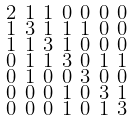<formula> <loc_0><loc_0><loc_500><loc_500>\begin{smallmatrix} 2 & 1 & 1 & 0 & 0 & 0 & 0 \\ 1 & 3 & 1 & 1 & 1 & 0 & 0 \\ 1 & 1 & 3 & 1 & 0 & 0 & 0 \\ 0 & 1 & 1 & 3 & 0 & 1 & 1 \\ 0 & 1 & 0 & 0 & 3 & 0 & 0 \\ 0 & 0 & 0 & 1 & 0 & 3 & 1 \\ 0 & 0 & 0 & 1 & 0 & 1 & 3 \end{smallmatrix}</formula> 